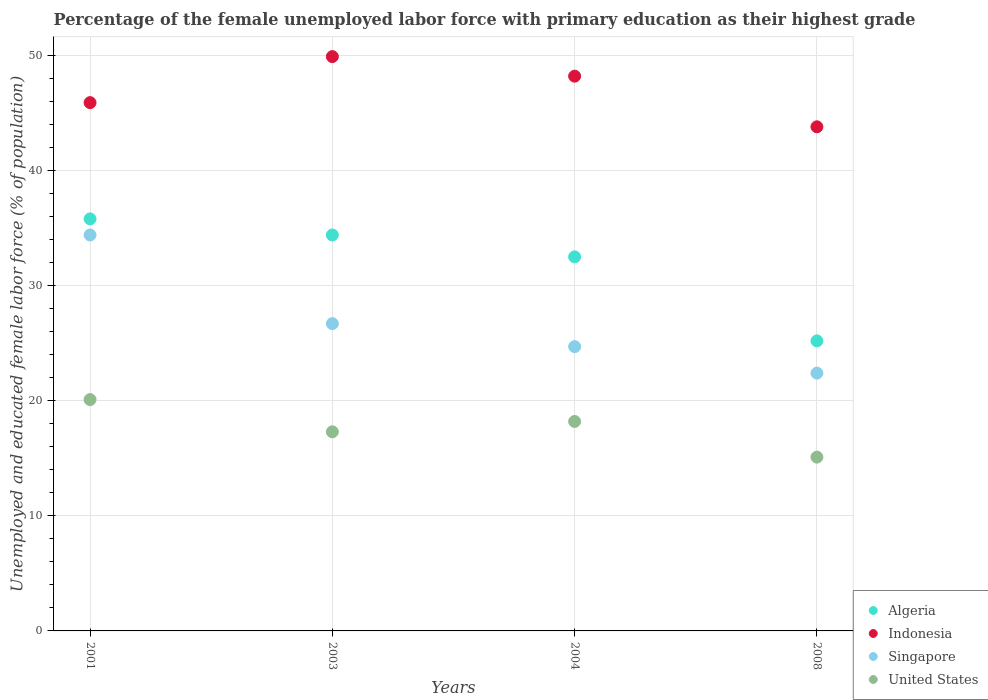What is the percentage of the unemployed female labor force with primary education in Indonesia in 2001?
Offer a very short reply. 45.9. Across all years, what is the maximum percentage of the unemployed female labor force with primary education in Indonesia?
Give a very brief answer. 49.9. Across all years, what is the minimum percentage of the unemployed female labor force with primary education in Indonesia?
Your answer should be very brief. 43.8. In which year was the percentage of the unemployed female labor force with primary education in Singapore maximum?
Your answer should be compact. 2001. What is the total percentage of the unemployed female labor force with primary education in Algeria in the graph?
Make the answer very short. 127.9. What is the difference between the percentage of the unemployed female labor force with primary education in Singapore in 2001 and that in 2003?
Provide a succinct answer. 7.7. What is the difference between the percentage of the unemployed female labor force with primary education in United States in 2003 and the percentage of the unemployed female labor force with primary education in Singapore in 2008?
Ensure brevity in your answer.  -5.1. What is the average percentage of the unemployed female labor force with primary education in Indonesia per year?
Your answer should be very brief. 46.95. In the year 2003, what is the difference between the percentage of the unemployed female labor force with primary education in United States and percentage of the unemployed female labor force with primary education in Singapore?
Provide a succinct answer. -9.4. What is the ratio of the percentage of the unemployed female labor force with primary education in Singapore in 2003 to that in 2008?
Ensure brevity in your answer.  1.19. Is the percentage of the unemployed female labor force with primary education in Indonesia in 2001 less than that in 2004?
Keep it short and to the point. Yes. What is the difference between the highest and the second highest percentage of the unemployed female labor force with primary education in United States?
Your answer should be compact. 1.9. What is the difference between the highest and the lowest percentage of the unemployed female labor force with primary education in Algeria?
Keep it short and to the point. 10.6. In how many years, is the percentage of the unemployed female labor force with primary education in Algeria greater than the average percentage of the unemployed female labor force with primary education in Algeria taken over all years?
Offer a very short reply. 3. Is the sum of the percentage of the unemployed female labor force with primary education in Singapore in 2003 and 2004 greater than the maximum percentage of the unemployed female labor force with primary education in Algeria across all years?
Your answer should be compact. Yes. Does the percentage of the unemployed female labor force with primary education in Algeria monotonically increase over the years?
Give a very brief answer. No. Is the percentage of the unemployed female labor force with primary education in Singapore strictly greater than the percentage of the unemployed female labor force with primary education in United States over the years?
Offer a very short reply. Yes. How many dotlines are there?
Offer a very short reply. 4. Are the values on the major ticks of Y-axis written in scientific E-notation?
Provide a succinct answer. No. Does the graph contain any zero values?
Your answer should be very brief. No. How many legend labels are there?
Offer a very short reply. 4. What is the title of the graph?
Provide a succinct answer. Percentage of the female unemployed labor force with primary education as their highest grade. What is the label or title of the Y-axis?
Your response must be concise. Unemployed and educated female labor force (% of population). What is the Unemployed and educated female labor force (% of population) of Algeria in 2001?
Keep it short and to the point. 35.8. What is the Unemployed and educated female labor force (% of population) of Indonesia in 2001?
Your answer should be compact. 45.9. What is the Unemployed and educated female labor force (% of population) in Singapore in 2001?
Your answer should be compact. 34.4. What is the Unemployed and educated female labor force (% of population) in United States in 2001?
Offer a terse response. 20.1. What is the Unemployed and educated female labor force (% of population) in Algeria in 2003?
Give a very brief answer. 34.4. What is the Unemployed and educated female labor force (% of population) of Indonesia in 2003?
Keep it short and to the point. 49.9. What is the Unemployed and educated female labor force (% of population) of Singapore in 2003?
Offer a terse response. 26.7. What is the Unemployed and educated female labor force (% of population) in United States in 2003?
Give a very brief answer. 17.3. What is the Unemployed and educated female labor force (% of population) in Algeria in 2004?
Your answer should be very brief. 32.5. What is the Unemployed and educated female labor force (% of population) of Indonesia in 2004?
Ensure brevity in your answer.  48.2. What is the Unemployed and educated female labor force (% of population) of Singapore in 2004?
Ensure brevity in your answer.  24.7. What is the Unemployed and educated female labor force (% of population) in United States in 2004?
Provide a short and direct response. 18.2. What is the Unemployed and educated female labor force (% of population) in Algeria in 2008?
Your answer should be compact. 25.2. What is the Unemployed and educated female labor force (% of population) in Indonesia in 2008?
Keep it short and to the point. 43.8. What is the Unemployed and educated female labor force (% of population) of Singapore in 2008?
Provide a succinct answer. 22.4. What is the Unemployed and educated female labor force (% of population) in United States in 2008?
Ensure brevity in your answer.  15.1. Across all years, what is the maximum Unemployed and educated female labor force (% of population) of Algeria?
Keep it short and to the point. 35.8. Across all years, what is the maximum Unemployed and educated female labor force (% of population) in Indonesia?
Provide a succinct answer. 49.9. Across all years, what is the maximum Unemployed and educated female labor force (% of population) in Singapore?
Offer a very short reply. 34.4. Across all years, what is the maximum Unemployed and educated female labor force (% of population) of United States?
Your response must be concise. 20.1. Across all years, what is the minimum Unemployed and educated female labor force (% of population) of Algeria?
Keep it short and to the point. 25.2. Across all years, what is the minimum Unemployed and educated female labor force (% of population) in Indonesia?
Offer a terse response. 43.8. Across all years, what is the minimum Unemployed and educated female labor force (% of population) of Singapore?
Your response must be concise. 22.4. Across all years, what is the minimum Unemployed and educated female labor force (% of population) in United States?
Provide a succinct answer. 15.1. What is the total Unemployed and educated female labor force (% of population) of Algeria in the graph?
Provide a short and direct response. 127.9. What is the total Unemployed and educated female labor force (% of population) in Indonesia in the graph?
Offer a terse response. 187.8. What is the total Unemployed and educated female labor force (% of population) in Singapore in the graph?
Your answer should be compact. 108.2. What is the total Unemployed and educated female labor force (% of population) in United States in the graph?
Provide a succinct answer. 70.7. What is the difference between the Unemployed and educated female labor force (% of population) of Algeria in 2001 and that in 2003?
Provide a short and direct response. 1.4. What is the difference between the Unemployed and educated female labor force (% of population) of Indonesia in 2001 and that in 2003?
Provide a short and direct response. -4. What is the difference between the Unemployed and educated female labor force (% of population) of Singapore in 2001 and that in 2003?
Your response must be concise. 7.7. What is the difference between the Unemployed and educated female labor force (% of population) in Indonesia in 2001 and that in 2008?
Your response must be concise. 2.1. What is the difference between the Unemployed and educated female labor force (% of population) in Singapore in 2001 and that in 2008?
Your answer should be very brief. 12. What is the difference between the Unemployed and educated female labor force (% of population) of Algeria in 2003 and that in 2004?
Make the answer very short. 1.9. What is the difference between the Unemployed and educated female labor force (% of population) in United States in 2003 and that in 2004?
Provide a short and direct response. -0.9. What is the difference between the Unemployed and educated female labor force (% of population) of Algeria in 2003 and that in 2008?
Provide a short and direct response. 9.2. What is the difference between the Unemployed and educated female labor force (% of population) of Indonesia in 2003 and that in 2008?
Your answer should be very brief. 6.1. What is the difference between the Unemployed and educated female labor force (% of population) in United States in 2003 and that in 2008?
Offer a terse response. 2.2. What is the difference between the Unemployed and educated female labor force (% of population) in Indonesia in 2004 and that in 2008?
Make the answer very short. 4.4. What is the difference between the Unemployed and educated female labor force (% of population) of Singapore in 2004 and that in 2008?
Provide a succinct answer. 2.3. What is the difference between the Unemployed and educated female labor force (% of population) of United States in 2004 and that in 2008?
Your answer should be compact. 3.1. What is the difference between the Unemployed and educated female labor force (% of population) in Algeria in 2001 and the Unemployed and educated female labor force (% of population) in Indonesia in 2003?
Give a very brief answer. -14.1. What is the difference between the Unemployed and educated female labor force (% of population) in Indonesia in 2001 and the Unemployed and educated female labor force (% of population) in United States in 2003?
Provide a succinct answer. 28.6. What is the difference between the Unemployed and educated female labor force (% of population) in Algeria in 2001 and the Unemployed and educated female labor force (% of population) in Indonesia in 2004?
Your answer should be compact. -12.4. What is the difference between the Unemployed and educated female labor force (% of population) of Indonesia in 2001 and the Unemployed and educated female labor force (% of population) of Singapore in 2004?
Give a very brief answer. 21.2. What is the difference between the Unemployed and educated female labor force (% of population) in Indonesia in 2001 and the Unemployed and educated female labor force (% of population) in United States in 2004?
Provide a succinct answer. 27.7. What is the difference between the Unemployed and educated female labor force (% of population) in Singapore in 2001 and the Unemployed and educated female labor force (% of population) in United States in 2004?
Give a very brief answer. 16.2. What is the difference between the Unemployed and educated female labor force (% of population) of Algeria in 2001 and the Unemployed and educated female labor force (% of population) of Indonesia in 2008?
Your answer should be very brief. -8. What is the difference between the Unemployed and educated female labor force (% of population) of Algeria in 2001 and the Unemployed and educated female labor force (% of population) of Singapore in 2008?
Offer a terse response. 13.4. What is the difference between the Unemployed and educated female labor force (% of population) in Algeria in 2001 and the Unemployed and educated female labor force (% of population) in United States in 2008?
Ensure brevity in your answer.  20.7. What is the difference between the Unemployed and educated female labor force (% of population) of Indonesia in 2001 and the Unemployed and educated female labor force (% of population) of Singapore in 2008?
Your answer should be very brief. 23.5. What is the difference between the Unemployed and educated female labor force (% of population) of Indonesia in 2001 and the Unemployed and educated female labor force (% of population) of United States in 2008?
Offer a terse response. 30.8. What is the difference between the Unemployed and educated female labor force (% of population) of Singapore in 2001 and the Unemployed and educated female labor force (% of population) of United States in 2008?
Your answer should be very brief. 19.3. What is the difference between the Unemployed and educated female labor force (% of population) in Algeria in 2003 and the Unemployed and educated female labor force (% of population) in Singapore in 2004?
Keep it short and to the point. 9.7. What is the difference between the Unemployed and educated female labor force (% of population) in Algeria in 2003 and the Unemployed and educated female labor force (% of population) in United States in 2004?
Provide a succinct answer. 16.2. What is the difference between the Unemployed and educated female labor force (% of population) of Indonesia in 2003 and the Unemployed and educated female labor force (% of population) of Singapore in 2004?
Offer a terse response. 25.2. What is the difference between the Unemployed and educated female labor force (% of population) in Indonesia in 2003 and the Unemployed and educated female labor force (% of population) in United States in 2004?
Offer a terse response. 31.7. What is the difference between the Unemployed and educated female labor force (% of population) of Singapore in 2003 and the Unemployed and educated female labor force (% of population) of United States in 2004?
Give a very brief answer. 8.5. What is the difference between the Unemployed and educated female labor force (% of population) of Algeria in 2003 and the Unemployed and educated female labor force (% of population) of Singapore in 2008?
Offer a terse response. 12. What is the difference between the Unemployed and educated female labor force (% of population) in Algeria in 2003 and the Unemployed and educated female labor force (% of population) in United States in 2008?
Offer a very short reply. 19.3. What is the difference between the Unemployed and educated female labor force (% of population) of Indonesia in 2003 and the Unemployed and educated female labor force (% of population) of Singapore in 2008?
Your response must be concise. 27.5. What is the difference between the Unemployed and educated female labor force (% of population) in Indonesia in 2003 and the Unemployed and educated female labor force (% of population) in United States in 2008?
Provide a short and direct response. 34.8. What is the difference between the Unemployed and educated female labor force (% of population) in Algeria in 2004 and the Unemployed and educated female labor force (% of population) in Singapore in 2008?
Provide a short and direct response. 10.1. What is the difference between the Unemployed and educated female labor force (% of population) of Indonesia in 2004 and the Unemployed and educated female labor force (% of population) of Singapore in 2008?
Provide a succinct answer. 25.8. What is the difference between the Unemployed and educated female labor force (% of population) in Indonesia in 2004 and the Unemployed and educated female labor force (% of population) in United States in 2008?
Make the answer very short. 33.1. What is the average Unemployed and educated female labor force (% of population) in Algeria per year?
Offer a very short reply. 31.98. What is the average Unemployed and educated female labor force (% of population) of Indonesia per year?
Offer a terse response. 46.95. What is the average Unemployed and educated female labor force (% of population) of Singapore per year?
Offer a terse response. 27.05. What is the average Unemployed and educated female labor force (% of population) of United States per year?
Offer a terse response. 17.68. In the year 2001, what is the difference between the Unemployed and educated female labor force (% of population) of Algeria and Unemployed and educated female labor force (% of population) of United States?
Ensure brevity in your answer.  15.7. In the year 2001, what is the difference between the Unemployed and educated female labor force (% of population) in Indonesia and Unemployed and educated female labor force (% of population) in Singapore?
Your answer should be very brief. 11.5. In the year 2001, what is the difference between the Unemployed and educated female labor force (% of population) in Indonesia and Unemployed and educated female labor force (% of population) in United States?
Provide a short and direct response. 25.8. In the year 2003, what is the difference between the Unemployed and educated female labor force (% of population) of Algeria and Unemployed and educated female labor force (% of population) of Indonesia?
Ensure brevity in your answer.  -15.5. In the year 2003, what is the difference between the Unemployed and educated female labor force (% of population) of Algeria and Unemployed and educated female labor force (% of population) of United States?
Give a very brief answer. 17.1. In the year 2003, what is the difference between the Unemployed and educated female labor force (% of population) in Indonesia and Unemployed and educated female labor force (% of population) in Singapore?
Give a very brief answer. 23.2. In the year 2003, what is the difference between the Unemployed and educated female labor force (% of population) of Indonesia and Unemployed and educated female labor force (% of population) of United States?
Give a very brief answer. 32.6. In the year 2003, what is the difference between the Unemployed and educated female labor force (% of population) in Singapore and Unemployed and educated female labor force (% of population) in United States?
Keep it short and to the point. 9.4. In the year 2004, what is the difference between the Unemployed and educated female labor force (% of population) in Algeria and Unemployed and educated female labor force (% of population) in Indonesia?
Offer a terse response. -15.7. In the year 2004, what is the difference between the Unemployed and educated female labor force (% of population) in Indonesia and Unemployed and educated female labor force (% of population) in United States?
Keep it short and to the point. 30. In the year 2004, what is the difference between the Unemployed and educated female labor force (% of population) of Singapore and Unemployed and educated female labor force (% of population) of United States?
Your answer should be very brief. 6.5. In the year 2008, what is the difference between the Unemployed and educated female labor force (% of population) in Algeria and Unemployed and educated female labor force (% of population) in Indonesia?
Offer a very short reply. -18.6. In the year 2008, what is the difference between the Unemployed and educated female labor force (% of population) in Indonesia and Unemployed and educated female labor force (% of population) in Singapore?
Your answer should be very brief. 21.4. In the year 2008, what is the difference between the Unemployed and educated female labor force (% of population) in Indonesia and Unemployed and educated female labor force (% of population) in United States?
Make the answer very short. 28.7. What is the ratio of the Unemployed and educated female labor force (% of population) of Algeria in 2001 to that in 2003?
Keep it short and to the point. 1.04. What is the ratio of the Unemployed and educated female labor force (% of population) of Indonesia in 2001 to that in 2003?
Your answer should be very brief. 0.92. What is the ratio of the Unemployed and educated female labor force (% of population) in Singapore in 2001 to that in 2003?
Your answer should be very brief. 1.29. What is the ratio of the Unemployed and educated female labor force (% of population) in United States in 2001 to that in 2003?
Make the answer very short. 1.16. What is the ratio of the Unemployed and educated female labor force (% of population) in Algeria in 2001 to that in 2004?
Provide a succinct answer. 1.1. What is the ratio of the Unemployed and educated female labor force (% of population) of Indonesia in 2001 to that in 2004?
Ensure brevity in your answer.  0.95. What is the ratio of the Unemployed and educated female labor force (% of population) of Singapore in 2001 to that in 2004?
Your response must be concise. 1.39. What is the ratio of the Unemployed and educated female labor force (% of population) of United States in 2001 to that in 2004?
Keep it short and to the point. 1.1. What is the ratio of the Unemployed and educated female labor force (% of population) in Algeria in 2001 to that in 2008?
Your answer should be compact. 1.42. What is the ratio of the Unemployed and educated female labor force (% of population) in Indonesia in 2001 to that in 2008?
Provide a succinct answer. 1.05. What is the ratio of the Unemployed and educated female labor force (% of population) of Singapore in 2001 to that in 2008?
Offer a very short reply. 1.54. What is the ratio of the Unemployed and educated female labor force (% of population) in United States in 2001 to that in 2008?
Ensure brevity in your answer.  1.33. What is the ratio of the Unemployed and educated female labor force (% of population) of Algeria in 2003 to that in 2004?
Provide a succinct answer. 1.06. What is the ratio of the Unemployed and educated female labor force (% of population) of Indonesia in 2003 to that in 2004?
Your answer should be very brief. 1.04. What is the ratio of the Unemployed and educated female labor force (% of population) of Singapore in 2003 to that in 2004?
Make the answer very short. 1.08. What is the ratio of the Unemployed and educated female labor force (% of population) of United States in 2003 to that in 2004?
Ensure brevity in your answer.  0.95. What is the ratio of the Unemployed and educated female labor force (% of population) of Algeria in 2003 to that in 2008?
Offer a very short reply. 1.37. What is the ratio of the Unemployed and educated female labor force (% of population) of Indonesia in 2003 to that in 2008?
Offer a very short reply. 1.14. What is the ratio of the Unemployed and educated female labor force (% of population) of Singapore in 2003 to that in 2008?
Make the answer very short. 1.19. What is the ratio of the Unemployed and educated female labor force (% of population) of United States in 2003 to that in 2008?
Provide a succinct answer. 1.15. What is the ratio of the Unemployed and educated female labor force (% of population) in Algeria in 2004 to that in 2008?
Provide a succinct answer. 1.29. What is the ratio of the Unemployed and educated female labor force (% of population) in Indonesia in 2004 to that in 2008?
Give a very brief answer. 1.1. What is the ratio of the Unemployed and educated female labor force (% of population) of Singapore in 2004 to that in 2008?
Your answer should be compact. 1.1. What is the ratio of the Unemployed and educated female labor force (% of population) in United States in 2004 to that in 2008?
Give a very brief answer. 1.21. What is the difference between the highest and the second highest Unemployed and educated female labor force (% of population) of Algeria?
Keep it short and to the point. 1.4. What is the difference between the highest and the second highest Unemployed and educated female labor force (% of population) of Indonesia?
Your answer should be compact. 1.7. What is the difference between the highest and the lowest Unemployed and educated female labor force (% of population) in Algeria?
Offer a terse response. 10.6. What is the difference between the highest and the lowest Unemployed and educated female labor force (% of population) of Indonesia?
Your answer should be compact. 6.1. What is the difference between the highest and the lowest Unemployed and educated female labor force (% of population) of Singapore?
Your answer should be very brief. 12. What is the difference between the highest and the lowest Unemployed and educated female labor force (% of population) of United States?
Provide a succinct answer. 5. 